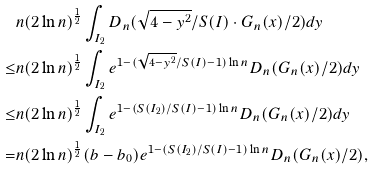Convert formula to latex. <formula><loc_0><loc_0><loc_500><loc_500>& n ( 2 \ln n ) ^ { \frac { 1 } { 2 } } \int _ { I _ { 2 } } D _ { n } ( \sqrt { 4 - y ^ { 2 } } / S ( I ) \cdot G _ { n } ( x ) / 2 ) d y \\ \leq & n ( 2 \ln n ) ^ { \frac { 1 } { 2 } } \int _ { I _ { 2 } } e ^ { 1 - ( \sqrt { 4 - y ^ { 2 } } / S ( I ) - 1 ) \ln n } D _ { n } ( G _ { n } ( x ) / 2 ) d y \\ \leq & n ( 2 \ln n ) ^ { \frac { 1 } { 2 } } \int _ { I _ { 2 } } e ^ { 1 - ( S ( I _ { 2 } ) / S ( I ) - 1 ) \ln n } D _ { n } ( G _ { n } ( x ) / 2 ) d y \\ = & n ( 2 \ln n ) ^ { \frac { 1 } { 2 } } ( b - b _ { 0 } ) e ^ { 1 - ( S ( I _ { 2 } ) / S ( I ) - 1 ) \ln n } D _ { n } ( G _ { n } ( x ) / 2 ) ,</formula> 